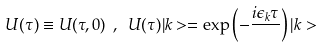Convert formula to latex. <formula><loc_0><loc_0><loc_500><loc_500>U ( \tau ) \equiv U ( \tau , 0 ) \ , \ U ( \tau ) | k > = \exp \left ( - \frac { i \epsilon _ { k } \tau } { } \right ) | k ></formula> 